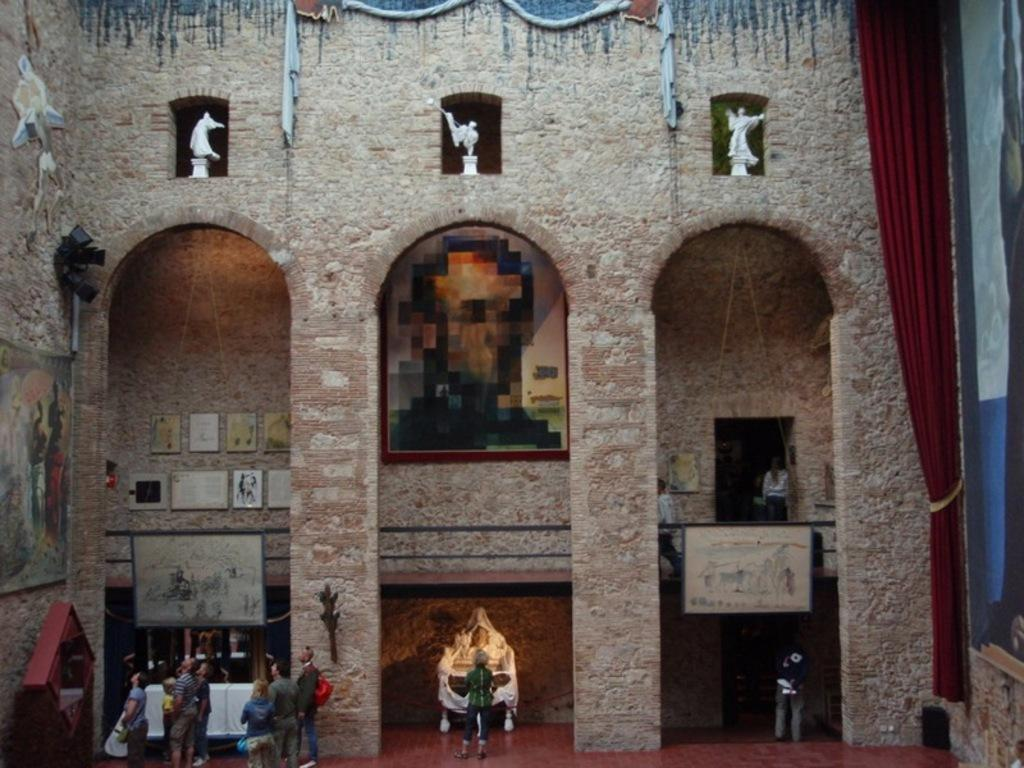How many people are in the image? There is a group of persons in the image, but the exact number is not specified. Where are the persons located in the image? The group of persons is standing at the bottom of the image. What can be seen in the background of the image? There is a wall and pillars in the background of the image. What type of sugar is being used to sweeten the cannon in the image? There is no cannon or sugar present in the image. What kind of feast is being prepared by the group of persons in the image? The image does not show any indication of a feast being prepared or served. 